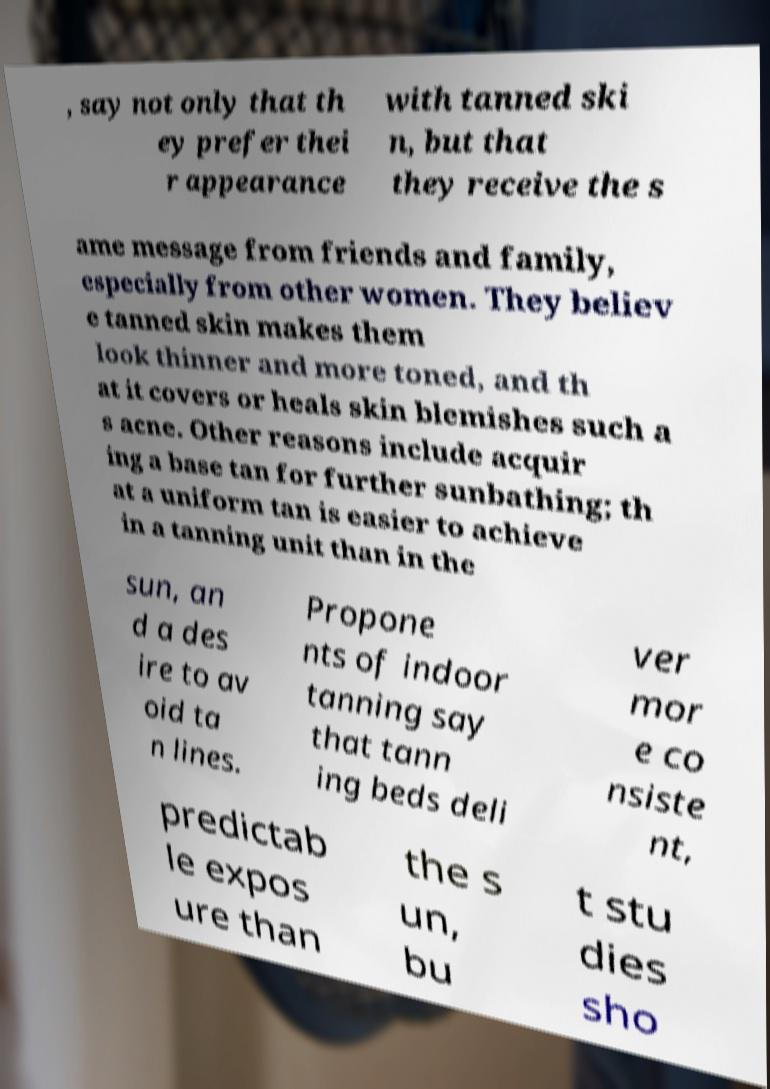Can you read and provide the text displayed in the image?This photo seems to have some interesting text. Can you extract and type it out for me? , say not only that th ey prefer thei r appearance with tanned ski n, but that they receive the s ame message from friends and family, especially from other women. They believ e tanned skin makes them look thinner and more toned, and th at it covers or heals skin blemishes such a s acne. Other reasons include acquir ing a base tan for further sunbathing; th at a uniform tan is easier to achieve in a tanning unit than in the sun, an d a des ire to av oid ta n lines. Propone nts of indoor tanning say that tann ing beds deli ver mor e co nsiste nt, predictab le expos ure than the s un, bu t stu dies sho 